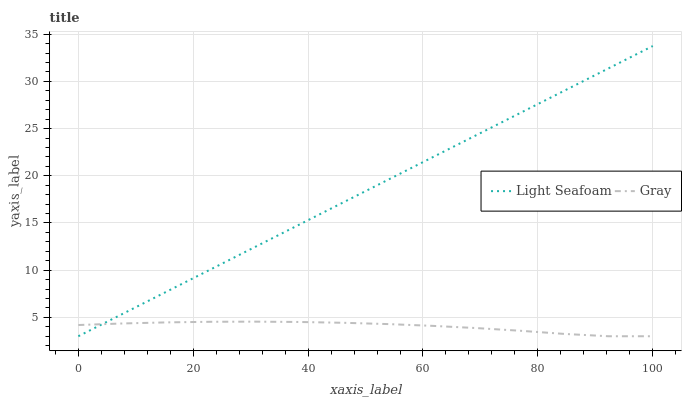Does Gray have the minimum area under the curve?
Answer yes or no. Yes. Does Light Seafoam have the maximum area under the curve?
Answer yes or no. Yes. Does Light Seafoam have the minimum area under the curve?
Answer yes or no. No. Is Light Seafoam the smoothest?
Answer yes or no. Yes. Is Gray the roughest?
Answer yes or no. Yes. Is Light Seafoam the roughest?
Answer yes or no. No. Does Gray have the lowest value?
Answer yes or no. Yes. Does Light Seafoam have the highest value?
Answer yes or no. Yes. Does Gray intersect Light Seafoam?
Answer yes or no. Yes. Is Gray less than Light Seafoam?
Answer yes or no. No. Is Gray greater than Light Seafoam?
Answer yes or no. No. 